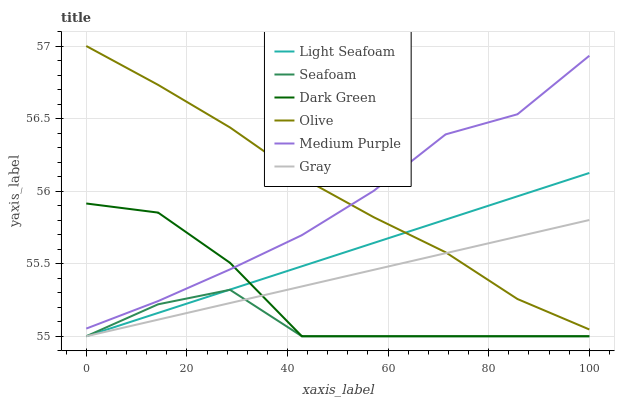Does Seafoam have the minimum area under the curve?
Answer yes or no. Yes. Does Olive have the maximum area under the curve?
Answer yes or no. Yes. Does Medium Purple have the minimum area under the curve?
Answer yes or no. No. Does Medium Purple have the maximum area under the curve?
Answer yes or no. No. Is Gray the smoothest?
Answer yes or no. Yes. Is Dark Green the roughest?
Answer yes or no. Yes. Is Seafoam the smoothest?
Answer yes or no. No. Is Seafoam the roughest?
Answer yes or no. No. Does Gray have the lowest value?
Answer yes or no. Yes. Does Medium Purple have the lowest value?
Answer yes or no. No. Does Olive have the highest value?
Answer yes or no. Yes. Does Medium Purple have the highest value?
Answer yes or no. No. Is Dark Green less than Olive?
Answer yes or no. Yes. Is Medium Purple greater than Light Seafoam?
Answer yes or no. Yes. Does Seafoam intersect Gray?
Answer yes or no. Yes. Is Seafoam less than Gray?
Answer yes or no. No. Is Seafoam greater than Gray?
Answer yes or no. No. Does Dark Green intersect Olive?
Answer yes or no. No. 